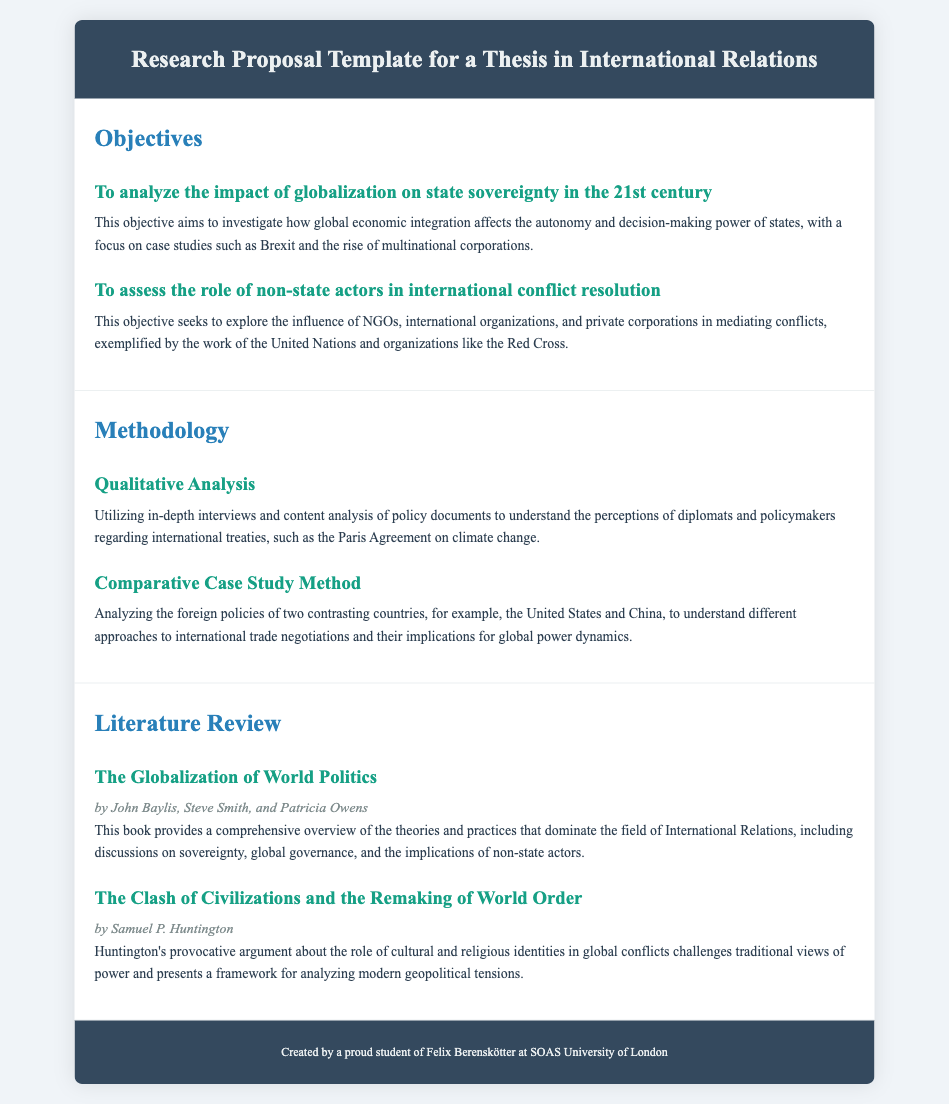What is the title of the document? The title of the document is presented in the header section, indicating the content and purpose of the document.
Answer: Research Proposal Template for a Thesis in International Relations How many objectives are listed in the document? The document contains a section titled "Objectives" with two specific objectives outlined.
Answer: 2 What methodology involves in-depth interviews? The document specifies using in-depth interviews as part of a particular methodology in the "Methodology" section.
Answer: Qualitative Analysis Who are the authors of "The Globalization of World Politics"? The authors of the book are mentioned in the "Literature Review" section, providing credits for the overview of International Relations theories.
Answer: John Baylis, Steve Smith, and Patricia Owens What cultural argument does Samuel P. Huntington present in his work? Huntington's argument is summarized in the description of his book, highlighting its central theme concerning cultural identities in global conflicts.
Answer: Clash of Civilizations What analytical method compares the foreign policies of the United States and China? The document identifies a specific methodology that focuses on understanding different approaches by analyzing foreign policies of two contrasting countries.
Answer: Comparative Case Study Method What type of document is this? The nature of the document is indicated by its title and structure, which is aimed at providing a structured approach for academic proposals.
Answer: Research Proposal Template 